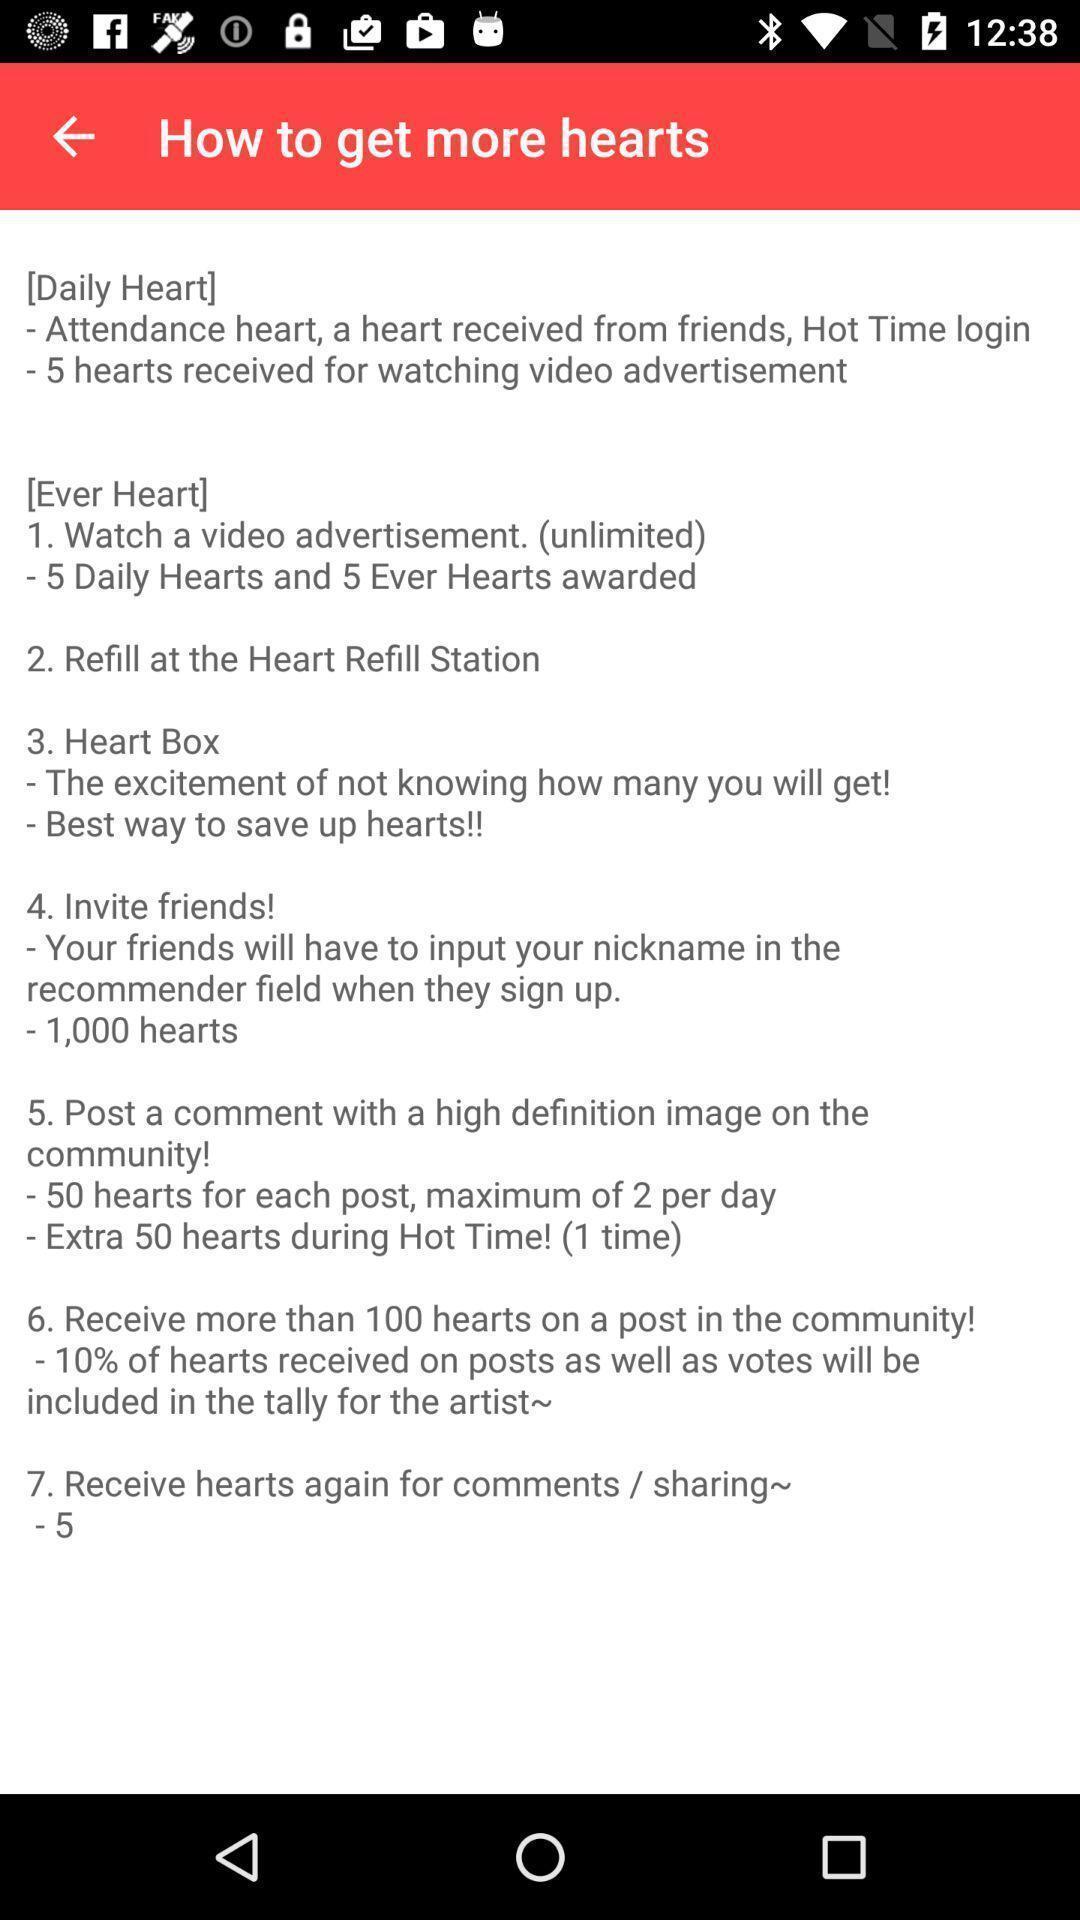Give me a summary of this screen capture. Screen shows on how to get more hearts. 